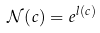<formula> <loc_0><loc_0><loc_500><loc_500>\mathcal { N } ( c ) = e ^ { l ( c ) }</formula> 